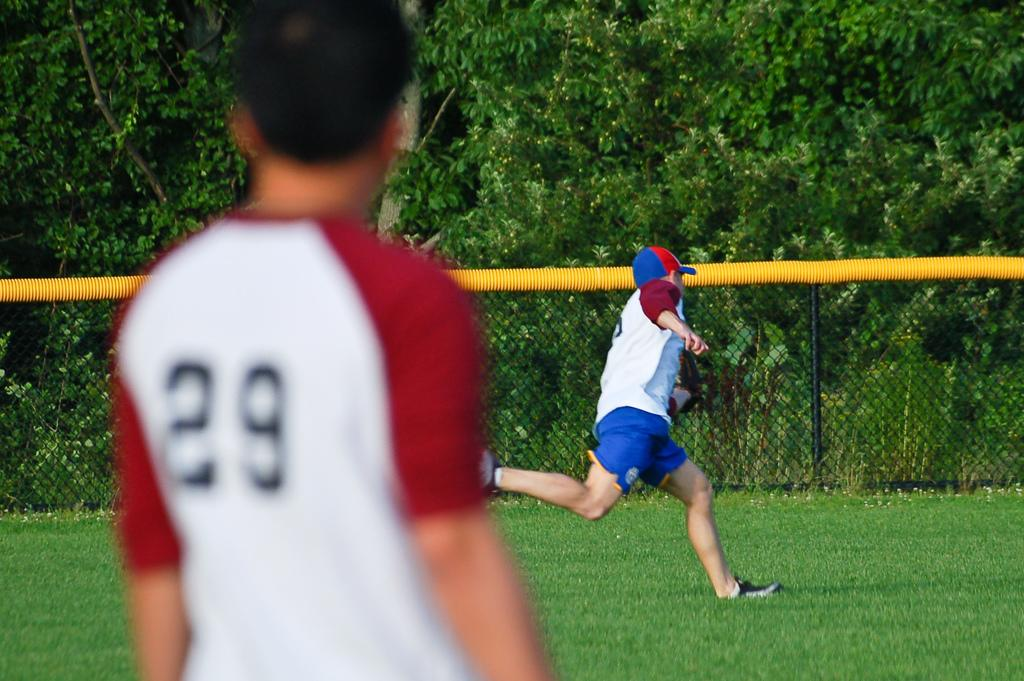What is happening in the foreground of the image? There is a person standing in the foreground of the image. What is happening in the middle of the image? There is a person running on the ground in the image. What can be seen around the ground in the image? There is a boundary around the ground. What is visible in the background of the image? There are trees in the background of the image. What type of impulse can be seen affecting the person running in the image? There is no indication of any impulse affecting the person running in the image. Is there a birthday celebration happening in the image? There is no information about a birthday celebration in the image. 